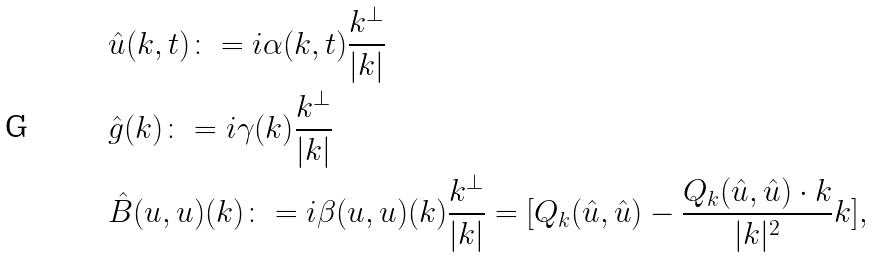Convert formula to latex. <formula><loc_0><loc_0><loc_500><loc_500>& \hat { u } ( k , t ) \colon = i \alpha ( k , t ) \frac { k ^ { \perp } } { | k | } \\ & \hat { g } ( k ) \colon = i \gamma ( k ) \frac { k ^ { \perp } } { | k | } \\ & \hat { B } ( u , u ) ( k ) \colon = i \beta ( u , u ) ( k ) \frac { k ^ { \perp } } { | k | } = [ Q _ { k } ( \hat { u } , \hat { u } ) - \frac { Q _ { k } ( \hat { u } , \hat { u } ) \cdot k } { | k | ^ { 2 } } k ] ,</formula> 